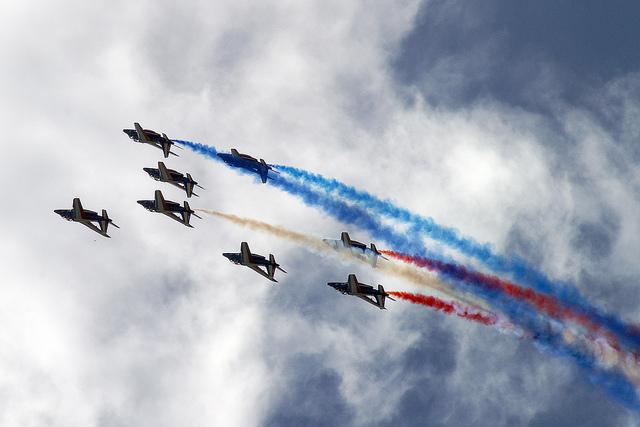What country are these planes from?
Concise answer only. Usa. Are they putting on an air show?
Be succinct. Yes. What color is the smoke?
Be succinct. Red, white & blue. 